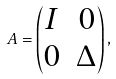<formula> <loc_0><loc_0><loc_500><loc_500>A = \begin{pmatrix} I & 0 \\ 0 & \Delta \end{pmatrix} ,</formula> 